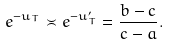Convert formula to latex. <formula><loc_0><loc_0><loc_500><loc_500>e ^ { - u _ { T } } \asymp e ^ { - u _ { T } ^ { \prime } } = \frac { b - c } { c - a } .</formula> 